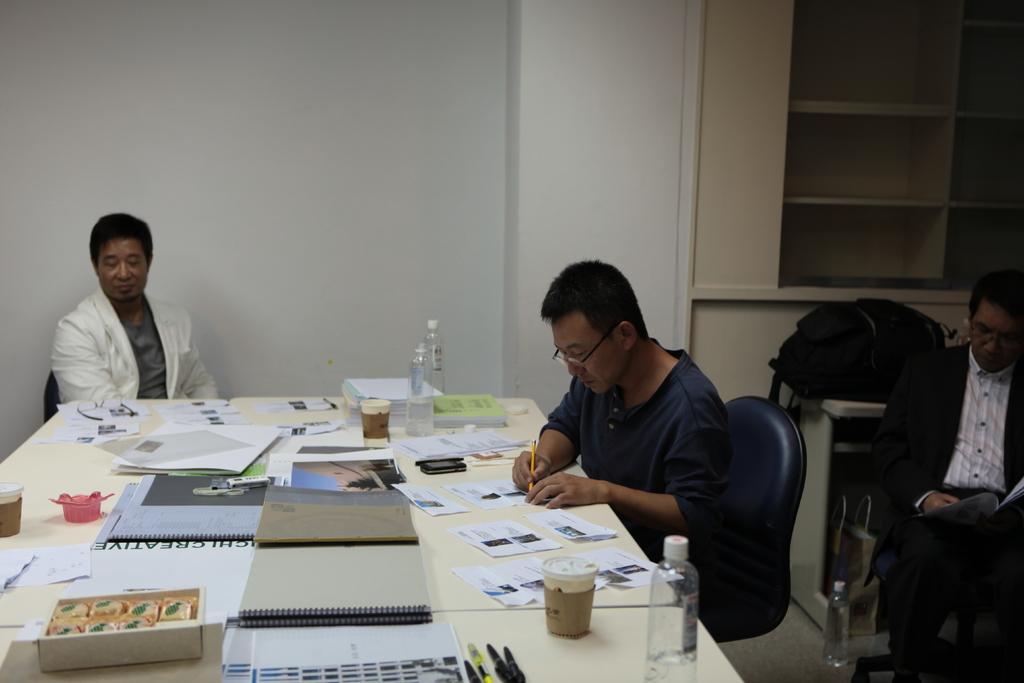Can you describe this image briefly? In this image I see 3 men sitting on a chair and this 2 men over here are wearing spectacles and there is a table in front of him and there are lot of papers, books, cups and bottles. In the background I can see wall, shelves, table and a bag on it. 